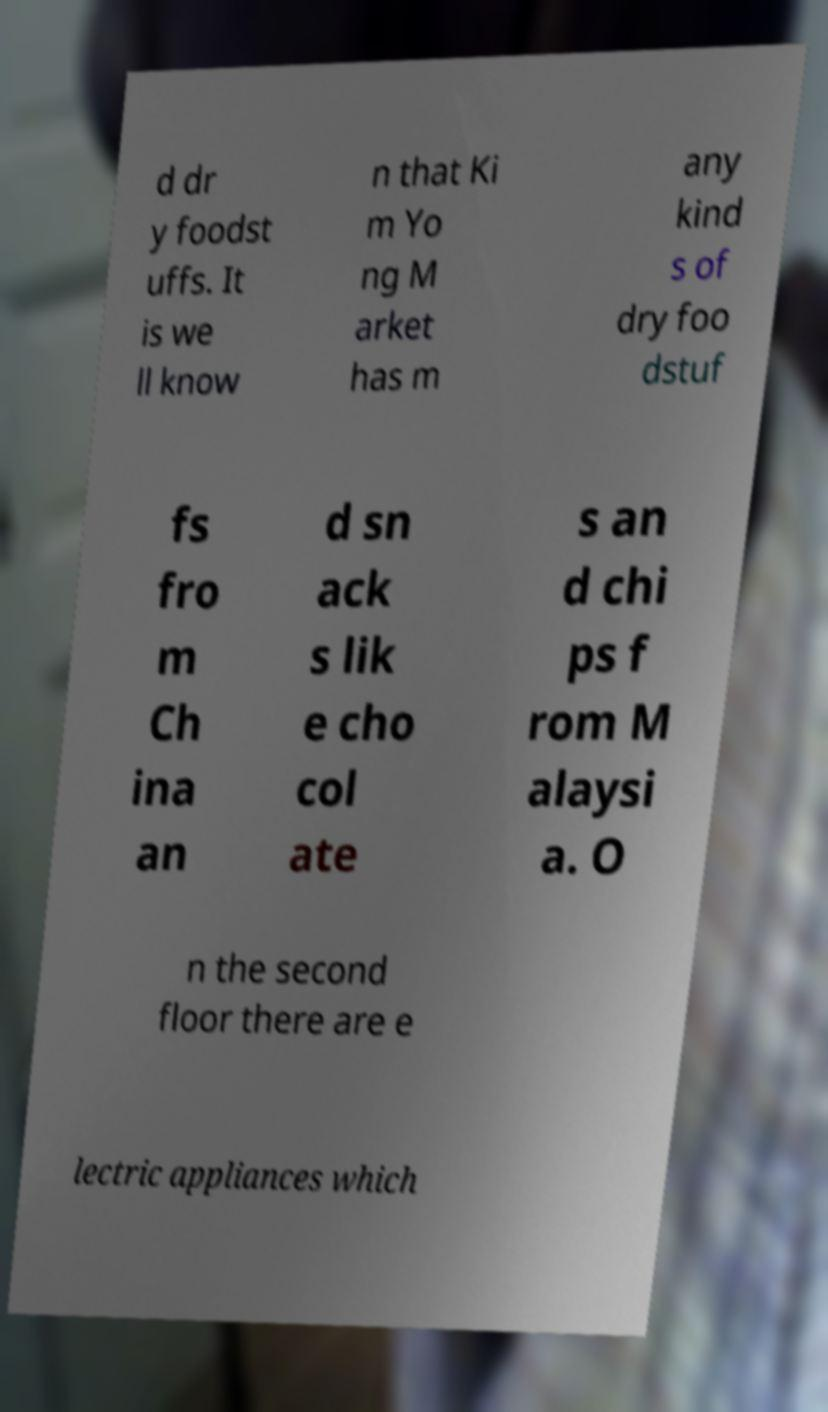What messages or text are displayed in this image? I need them in a readable, typed format. d dr y foodst uffs. It is we ll know n that Ki m Yo ng M arket has m any kind s of dry foo dstuf fs fro m Ch ina an d sn ack s lik e cho col ate s an d chi ps f rom M alaysi a. O n the second floor there are e lectric appliances which 